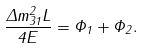Convert formula to latex. <formula><loc_0><loc_0><loc_500><loc_500>\frac { \Delta m ^ { 2 } _ { 3 1 } L } { 4 E } = \Phi _ { 1 } + \Phi _ { 2 } .</formula> 